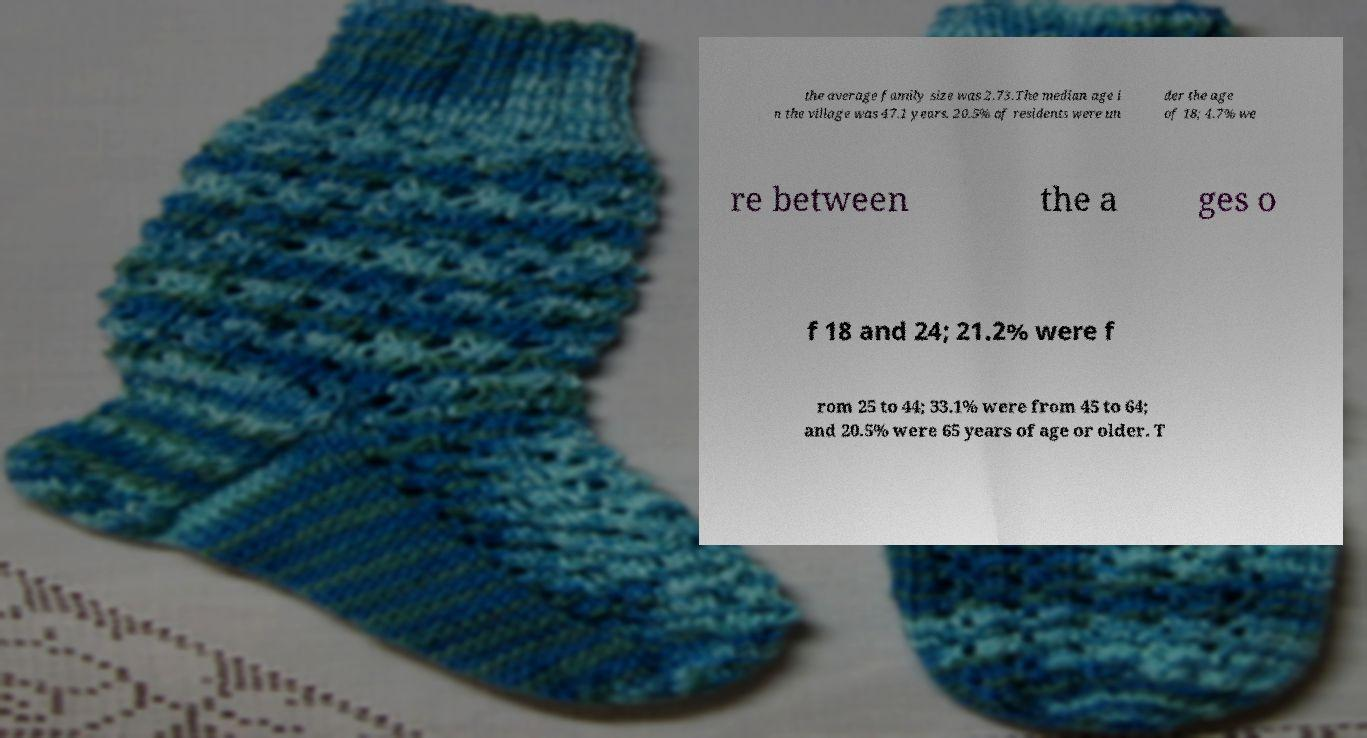Please identify and transcribe the text found in this image. the average family size was 2.73.The median age i n the village was 47.1 years. 20.5% of residents were un der the age of 18; 4.7% we re between the a ges o f 18 and 24; 21.2% were f rom 25 to 44; 33.1% were from 45 to 64; and 20.5% were 65 years of age or older. T 